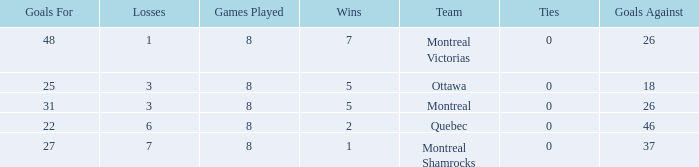How many losses did the team with 22 goals for andmore than 8 games played have? 0.0. Parse the full table. {'header': ['Goals For', 'Losses', 'Games Played', 'Wins', 'Team', 'Ties', 'Goals Against'], 'rows': [['48', '1', '8', '7', 'Montreal Victorias', '0', '26'], ['25', '3', '8', '5', 'Ottawa', '0', '18'], ['31', '3', '8', '5', 'Montreal', '0', '26'], ['22', '6', '8', '2', 'Quebec', '0', '46'], ['27', '7', '8', '1', 'Montreal Shamrocks', '0', '37']]} 